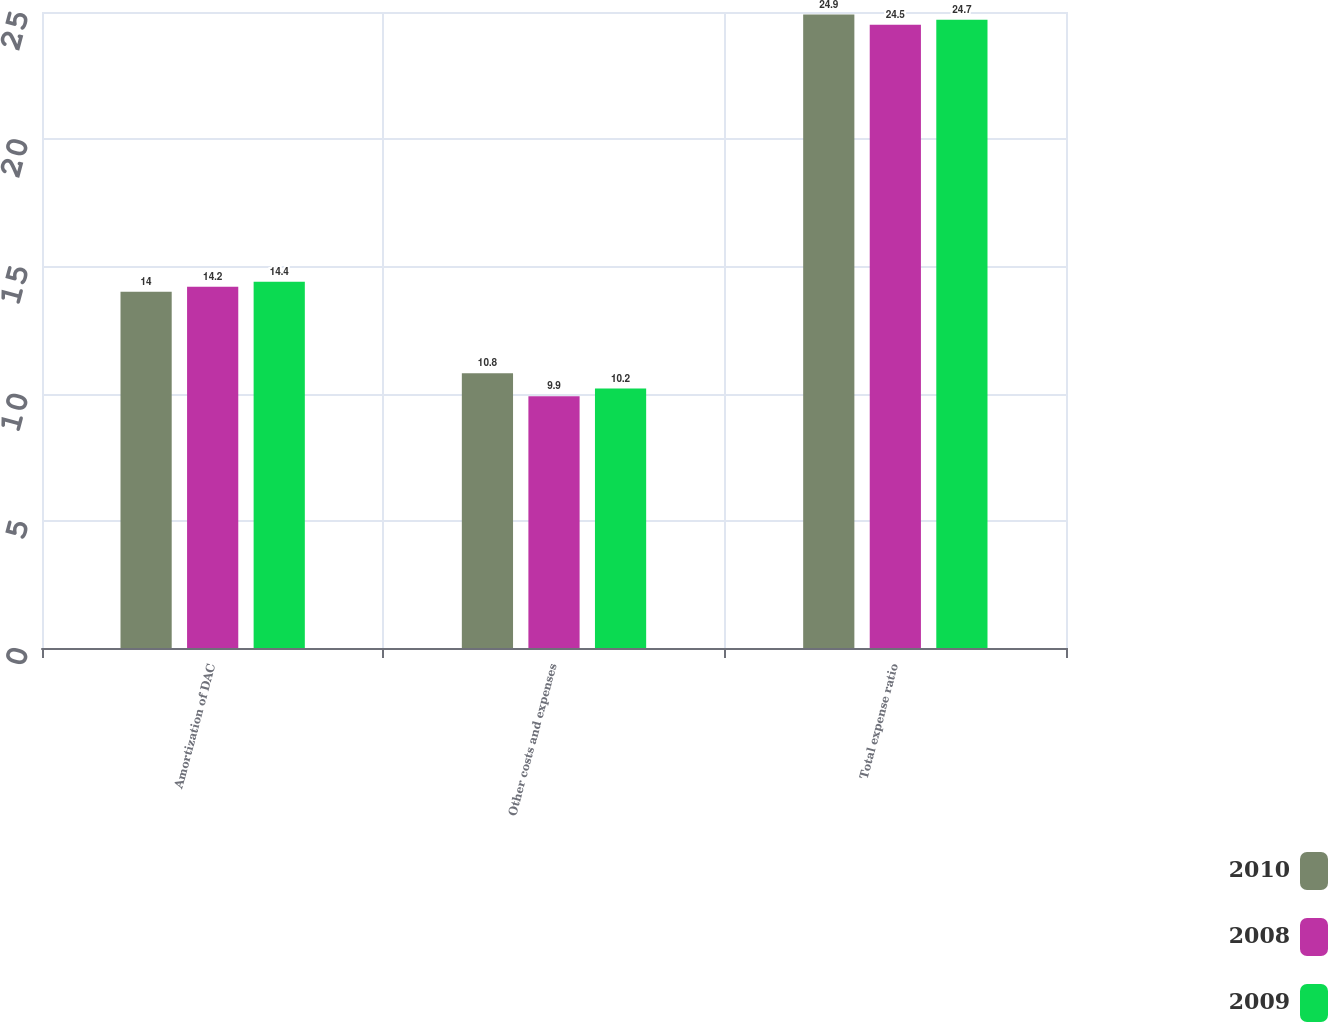Convert chart. <chart><loc_0><loc_0><loc_500><loc_500><stacked_bar_chart><ecel><fcel>Amortization of DAC<fcel>Other costs and expenses<fcel>Total expense ratio<nl><fcel>2010<fcel>14<fcel>10.8<fcel>24.9<nl><fcel>2008<fcel>14.2<fcel>9.9<fcel>24.5<nl><fcel>2009<fcel>14.4<fcel>10.2<fcel>24.7<nl></chart> 